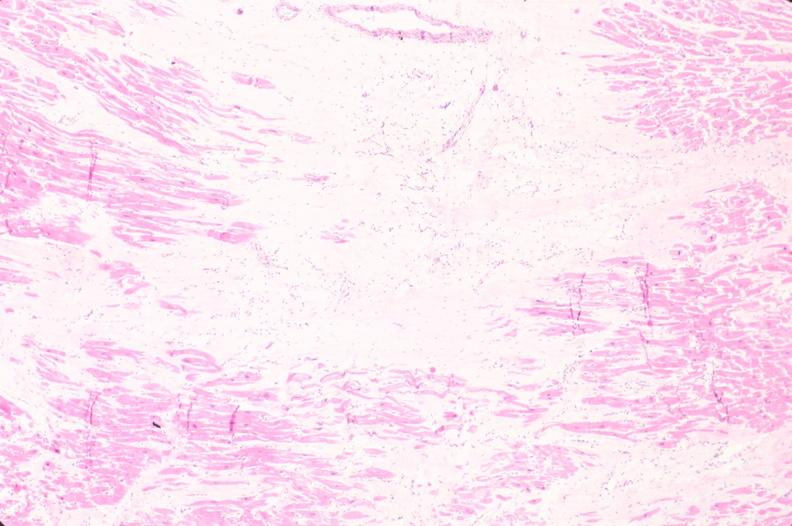s this typical lesion present?
Answer the question using a single word or phrase. No 